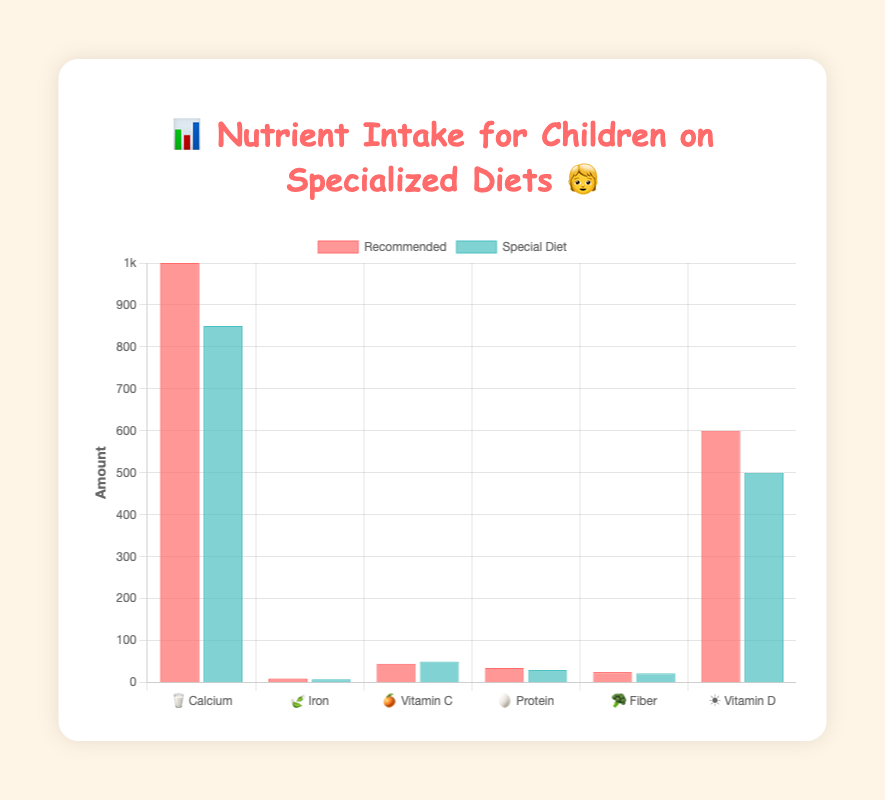Which nutrient has the highest recommended daily intake? The recommended daily intake for each nutrient is specified in the figure. The highest value among these is 1000 mg for Calcium.
Answer: Calcium Which nutrient has the largest gap between the recommended intake and the specialized diet intake? The gaps between recommended and specialized diet intakes are as follows: Calcium (150 mg), Iron (2 mg), Vitamin C (-5 mg), Protein (5 g), Fiber (3 g), Vitamin D (100 IU). The largest gap is 150 mg for Calcium.
Answer: Calcium Which nutrients meet or exceed the recommended levels on the specialized diet? Looking at the bars in the figure, only Vitamin C on the specialized diet (50 mg) exceeds the recommended intake (45 mg).
Answer: Vitamin C By how much does the intake of Vitamin D on the specialized diet fall short of the recommended level? The recommended level of Vitamin D is 600 IU, and the specialized diet intake is 500 IU. The shortfall is (600 - 500) IU.
Answer: 100 IU Are all the nutrients in the specialized diet under the recommended intake? We can see in the figure that only Vitamin C exceeds its recommended level, while all other nutrients are below the recommended intake.
Answer: No Which nutrient's intake is closest to its recommended level on a specialized diet? By examining the differences between recommended and specialized diet intakes: Calcium (150 mg), Iron (2 mg), Vitamin C (-5 mg), Protein (5 g), Fiber (3 g), Vitamin D (100 IU). The smallest difference is 2 mg for Iron.
Answer: Iron How does the intake of Protein in a specialized diet compare to the recommended intake? The figure shows that the intake of Protein in a specialized diet (30 g) is less than the recommended intake (35 g).
Answer: Less than Which nutrient has the second highest recommended intake? The recommended daily intake values are: Calcium (1000 mg), Iron (10 mg), Vitamin C (45 mg), Protein (35 g), Fiber (25 g), Vitamin D (600 IU). The second highest value is 600 IU for Vitamin D.
Answer: Vitamin D 